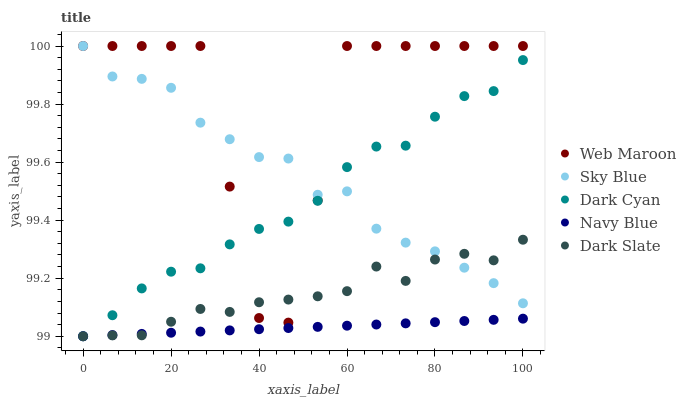Does Navy Blue have the minimum area under the curve?
Answer yes or no. Yes. Does Web Maroon have the maximum area under the curve?
Answer yes or no. Yes. Does Sky Blue have the minimum area under the curve?
Answer yes or no. No. Does Sky Blue have the maximum area under the curve?
Answer yes or no. No. Is Navy Blue the smoothest?
Answer yes or no. Yes. Is Web Maroon the roughest?
Answer yes or no. Yes. Is Sky Blue the smoothest?
Answer yes or no. No. Is Sky Blue the roughest?
Answer yes or no. No. Does Dark Cyan have the lowest value?
Answer yes or no. Yes. Does Web Maroon have the lowest value?
Answer yes or no. No. Does Web Maroon have the highest value?
Answer yes or no. Yes. Does Dark Slate have the highest value?
Answer yes or no. No. Is Navy Blue less than Sky Blue?
Answer yes or no. Yes. Is Sky Blue greater than Navy Blue?
Answer yes or no. Yes. Does Web Maroon intersect Dark Slate?
Answer yes or no. Yes. Is Web Maroon less than Dark Slate?
Answer yes or no. No. Is Web Maroon greater than Dark Slate?
Answer yes or no. No. Does Navy Blue intersect Sky Blue?
Answer yes or no. No. 